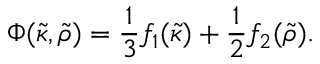<formula> <loc_0><loc_0><loc_500><loc_500>\Phi ( \tilde { \kappa } , \tilde { \rho } ) = \frac { 1 } { 3 } f _ { 1 } ( \tilde { \kappa } ) + \frac { 1 } { 2 } f _ { 2 } ( \tilde { \rho } ) .</formula> 